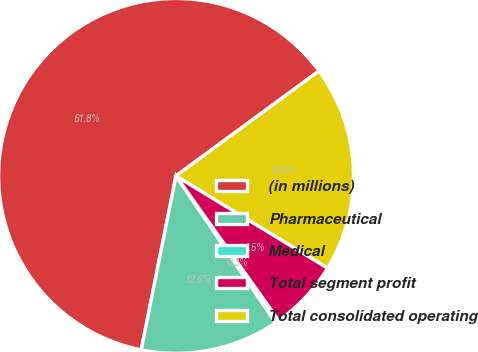Convert chart. <chart><loc_0><loc_0><loc_500><loc_500><pie_chart><fcel>(in millions)<fcel>Pharmaceutical<fcel>Medical<fcel>Total segment profit<fcel>Total consolidated operating<nl><fcel>61.78%<fcel>12.63%<fcel>0.34%<fcel>6.48%<fcel>18.77%<nl></chart> 